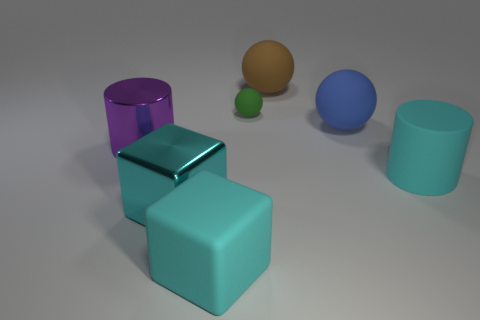Subtract all large spheres. How many spheres are left? 1 Add 2 cyan matte cylinders. How many objects exist? 9 Add 7 purple cylinders. How many purple cylinders are left? 8 Add 4 gray metal objects. How many gray metal objects exist? 4 Subtract 0 red cylinders. How many objects are left? 7 Subtract all blocks. How many objects are left? 5 Subtract all green cylinders. Subtract all red spheres. How many cylinders are left? 2 Subtract all tiny cylinders. Subtract all small matte things. How many objects are left? 6 